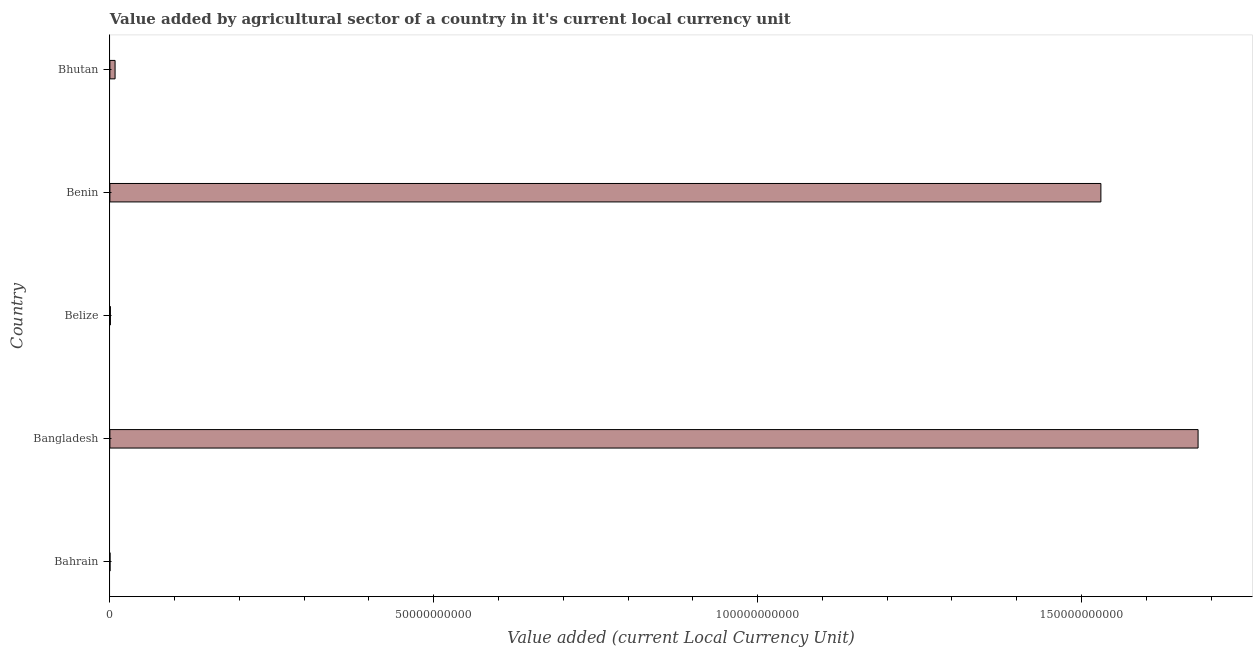What is the title of the graph?
Provide a succinct answer. Value added by agricultural sector of a country in it's current local currency unit. What is the label or title of the X-axis?
Provide a succinct answer. Value added (current Local Currency Unit). What is the value added by agriculture sector in Benin?
Offer a very short reply. 1.53e+11. Across all countries, what is the maximum value added by agriculture sector?
Your response must be concise. 1.68e+11. Across all countries, what is the minimum value added by agriculture sector?
Your response must be concise. 1.64e+07. In which country was the value added by agriculture sector minimum?
Give a very brief answer. Bahrain. What is the sum of the value added by agriculture sector?
Make the answer very short. 3.22e+11. What is the difference between the value added by agriculture sector in Belize and Benin?
Keep it short and to the point. -1.53e+11. What is the average value added by agriculture sector per country?
Keep it short and to the point. 6.44e+1. What is the median value added by agriculture sector?
Offer a very short reply. 8.01e+08. Is the value added by agriculture sector in Bangladesh less than that in Bhutan?
Your response must be concise. No. What is the difference between the highest and the second highest value added by agriculture sector?
Offer a very short reply. 1.50e+1. Is the sum of the value added by agriculture sector in Bangladesh and Benin greater than the maximum value added by agriculture sector across all countries?
Provide a succinct answer. Yes. What is the difference between the highest and the lowest value added by agriculture sector?
Make the answer very short. 1.68e+11. In how many countries, is the value added by agriculture sector greater than the average value added by agriculture sector taken over all countries?
Make the answer very short. 2. Are all the bars in the graph horizontal?
Your answer should be compact. Yes. What is the difference between two consecutive major ticks on the X-axis?
Make the answer very short. 5.00e+1. What is the Value added (current Local Currency Unit) in Bahrain?
Make the answer very short. 1.64e+07. What is the Value added (current Local Currency Unit) of Bangladesh?
Provide a succinct answer. 1.68e+11. What is the Value added (current Local Currency Unit) of Belize?
Provide a short and direct response. 7.74e+07. What is the Value added (current Local Currency Unit) of Benin?
Offer a terse response. 1.53e+11. What is the Value added (current Local Currency Unit) of Bhutan?
Give a very brief answer. 8.01e+08. What is the difference between the Value added (current Local Currency Unit) in Bahrain and Bangladesh?
Your answer should be compact. -1.68e+11. What is the difference between the Value added (current Local Currency Unit) in Bahrain and Belize?
Offer a very short reply. -6.10e+07. What is the difference between the Value added (current Local Currency Unit) in Bahrain and Benin?
Provide a succinct answer. -1.53e+11. What is the difference between the Value added (current Local Currency Unit) in Bahrain and Bhutan?
Ensure brevity in your answer.  -7.85e+08. What is the difference between the Value added (current Local Currency Unit) in Bangladesh and Belize?
Offer a very short reply. 1.68e+11. What is the difference between the Value added (current Local Currency Unit) in Bangladesh and Benin?
Ensure brevity in your answer.  1.50e+1. What is the difference between the Value added (current Local Currency Unit) in Bangladesh and Bhutan?
Your answer should be compact. 1.67e+11. What is the difference between the Value added (current Local Currency Unit) in Belize and Benin?
Ensure brevity in your answer.  -1.53e+11. What is the difference between the Value added (current Local Currency Unit) in Belize and Bhutan?
Ensure brevity in your answer.  -7.24e+08. What is the difference between the Value added (current Local Currency Unit) in Benin and Bhutan?
Your response must be concise. 1.52e+11. What is the ratio of the Value added (current Local Currency Unit) in Bahrain to that in Belize?
Make the answer very short. 0.21. What is the ratio of the Value added (current Local Currency Unit) in Bangladesh to that in Belize?
Offer a very short reply. 2170.62. What is the ratio of the Value added (current Local Currency Unit) in Bangladesh to that in Benin?
Give a very brief answer. 1.1. What is the ratio of the Value added (current Local Currency Unit) in Bangladesh to that in Bhutan?
Give a very brief answer. 209.68. What is the ratio of the Value added (current Local Currency Unit) in Belize to that in Bhutan?
Ensure brevity in your answer.  0.1. What is the ratio of the Value added (current Local Currency Unit) in Benin to that in Bhutan?
Your answer should be very brief. 190.95. 